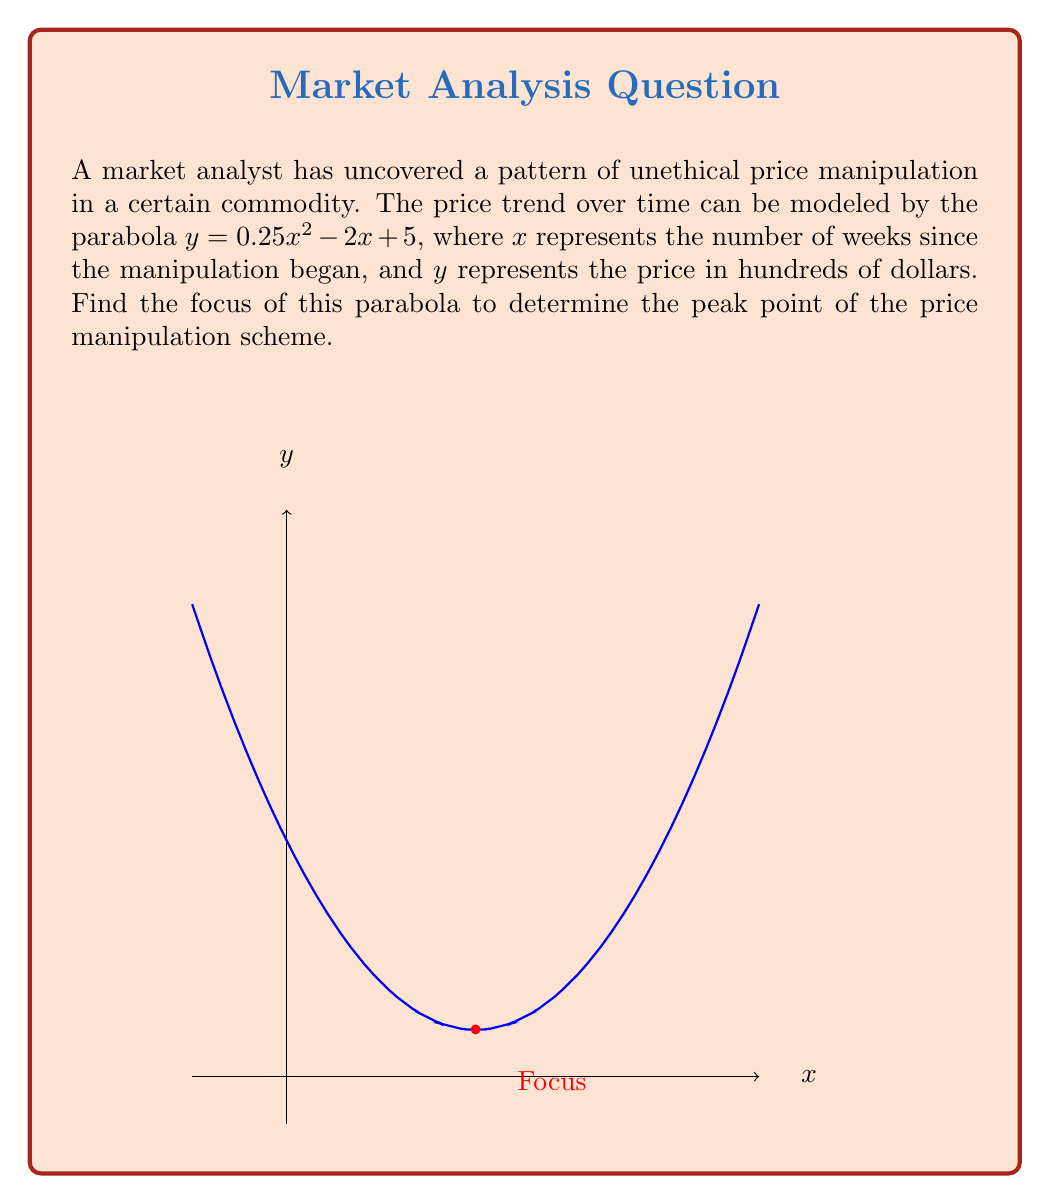Could you help me with this problem? To find the focus of the parabola, we'll follow these steps:

1) The general form of a parabola with a vertical axis of symmetry is:
   $y = a(x-h)^2 + k$
   where $(h,k)$ is the vertex and $a$ determines the direction and width.

2) Our parabola is in the form $y = 0.25x^2 - 2x + 5$. We need to rewrite it in vertex form.

3) To find $h$, we use the formula $h = -\frac{b}{2a}$, where $a = 0.25$ and $b = -2$:
   $h = -\frac{-2}{2(0.25)} = 4$

4) To find $k$, we substitute $x = 4$ into the original equation:
   $k = 0.25(4)^2 - 2(4) + 5 = 4 - 8 + 5 = 1$

5) So, the vertex is at $(4,1)$.

6) The parabola in vertex form is:
   $y = 0.25(x-4)^2 + 1$

7) For a parabola with equation $y = a(x-h)^2 + k$, the focus is located at $(h, k+\frac{1}{4a})$.

8) In our case, $h = 4$, $k = 1$, and $a = 0.25$.

9) Therefore, the y-coordinate of the focus is:
   $1 + \frac{1}{4(0.25)} = 1 + 1 = 2$

10) The focus is at $(4,2)$.
Answer: $(4,2)$ 